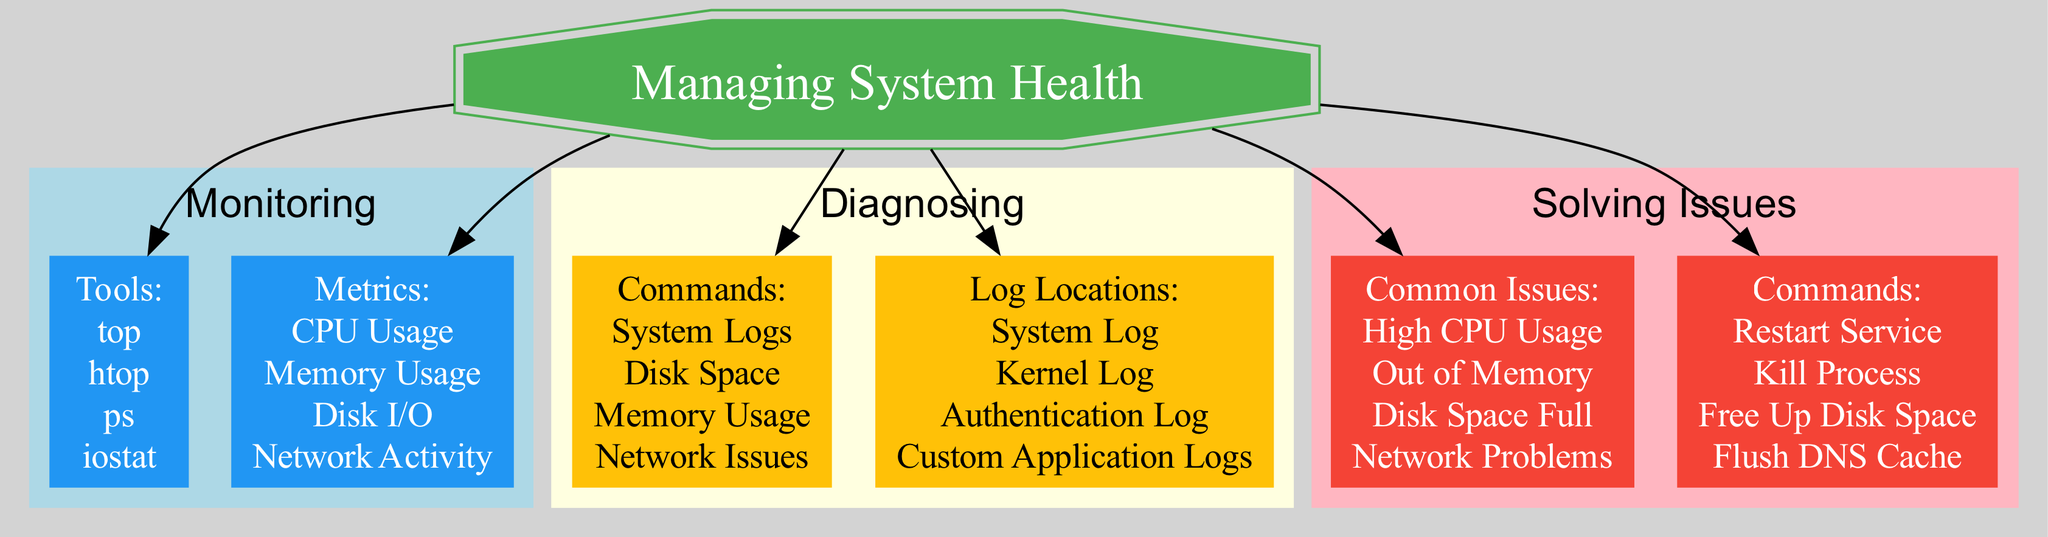What are the tools listed under Monitoring? The diagram includes a section under Monitoring that lists specific tools for system monitoring. By scanning the Monitoring subgraph, the tools are clearly outlined and can be directly extracted.
Answer: top, htop, ps, iostat How many commands are there in the Diagnosing section? In the Diagnosing subgraph, commands are explicitly listed, which can be counted. A quick enumeration of commands shows that there are four distinct commands presented.
Answer: 4 Which log location is associated with authentication? Within the Diagnosing subgraph, there is a specific section detailing log locations. By identifying the log associated with authentication, it can be found that one of the entries explicitly mentions authentication.
Answer: /var/log/auth.log What is the command for checking disk space? Referring to the Diagnosing commands, each command is listed adjacent to its function. By examining the commands section and identifying which command relates to disk space, we can find the specific command mentioned.
Answer: df -h Which issue can be solved by restarting the network manager? In the Solving Issues section, common issues are paired with their respective solutions. By analyzing these pairings, it is clear that a specific issue is linked to restarting the network manager.
Answer: Network Problems What is the command to free up disk space? Within the Solving Issues commands, each command is listed with its intended function. By identifying the action related to freeing disk space in this section, the command can be accurately pinpointed.
Answer: rm -rf /path/to/files Which metric is NOT listed under Monitoring? The Metrics section underneath Monitoring features various metrics. To answer correctly, one must discern which common metrics are excluded by cross-referencing with typical system health indicators.
Answer: (Any example metric not specified in 'CPU Usage', 'Memory Usage', 'Disk I/O', 'Network Activity') How many categories are there in the main diagram? The main diagram is organized into multiple categories, including Monitoring, Diagnosing, and Solving Issues. The total number of these categories can easily be counted by looking at the main structure.
Answer: 3 